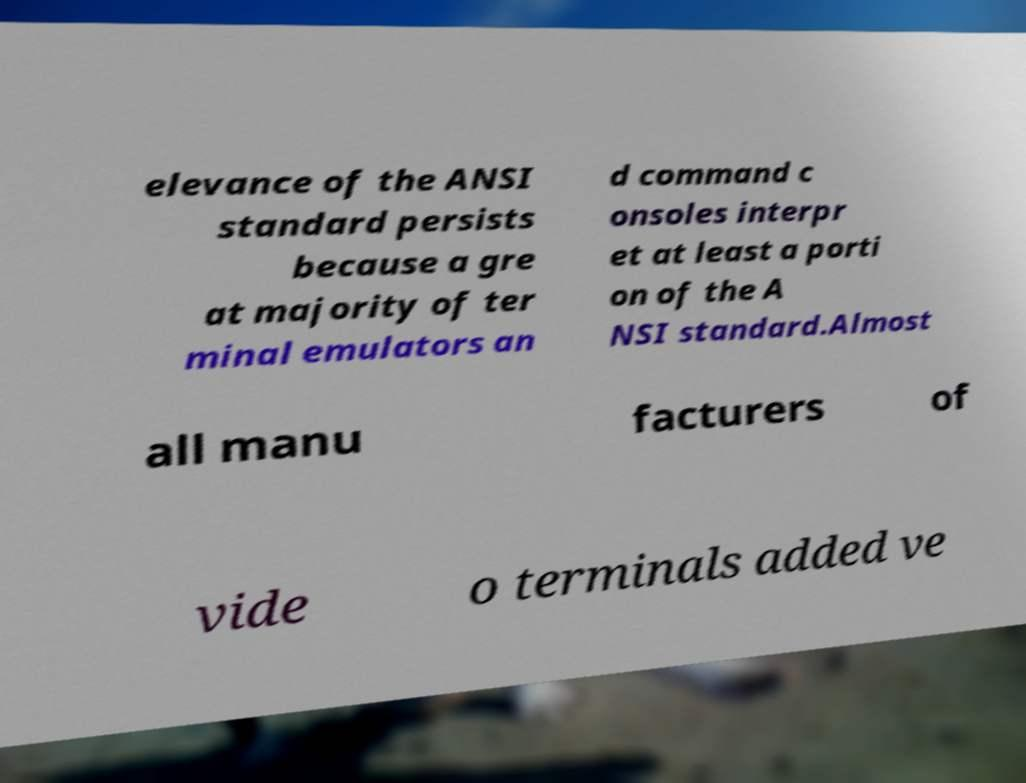What messages or text are displayed in this image? I need them in a readable, typed format. elevance of the ANSI standard persists because a gre at majority of ter minal emulators an d command c onsoles interpr et at least a porti on of the A NSI standard.Almost all manu facturers of vide o terminals added ve 